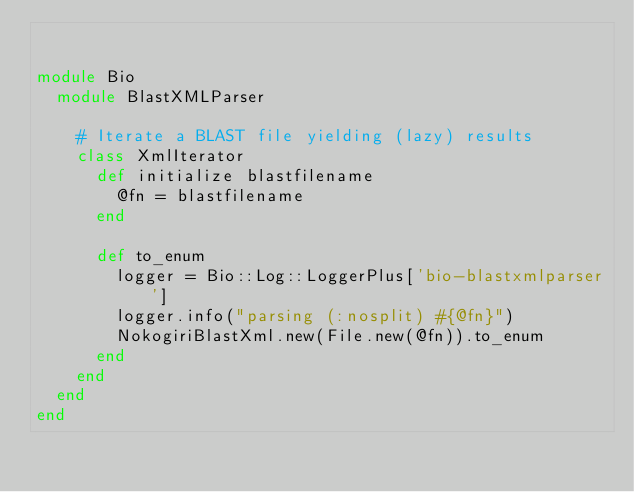<code> <loc_0><loc_0><loc_500><loc_500><_Ruby_>

module Bio
  module BlastXMLParser

    # Iterate a BLAST file yielding (lazy) results
    class XmlIterator
      def initialize blastfilename
        @fn = blastfilename
      end
      
      def to_enum
        logger = Bio::Log::LoggerPlus['bio-blastxmlparser']
        logger.info("parsing (:nosplit) #{@fn}")
        NokogiriBlastXml.new(File.new(@fn)).to_enum
      end
    end
  end
end
</code> 